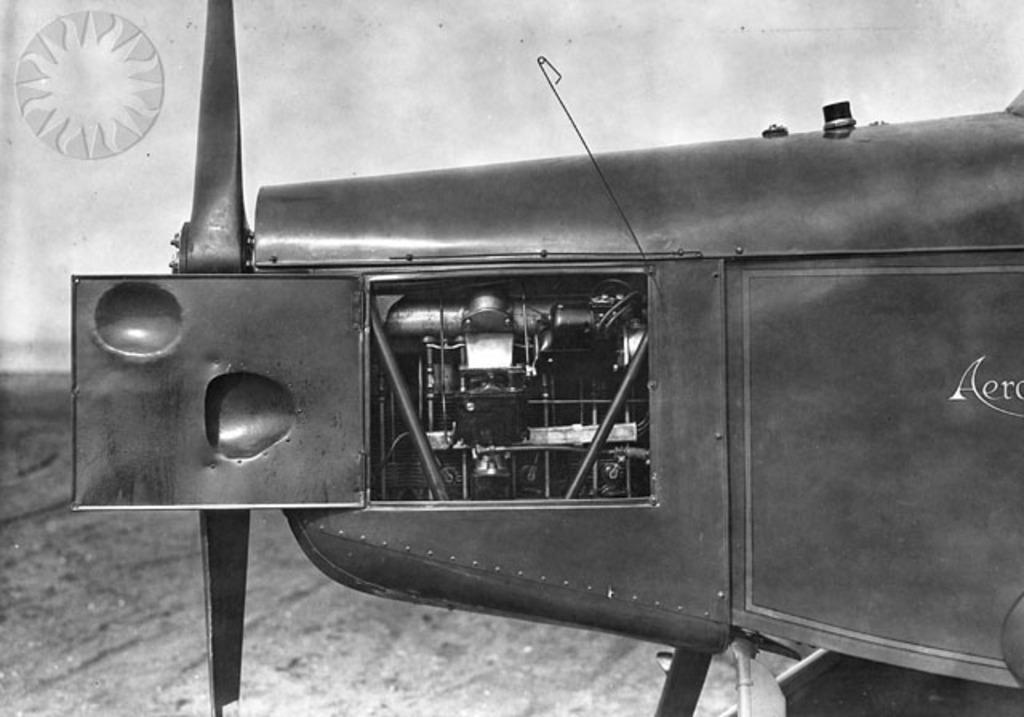Describe this image in one or two sentences. This is a zoomed in picture. In the foreground there is a black color object on which we can see the text. In the background we can see the ground and a white color object. 